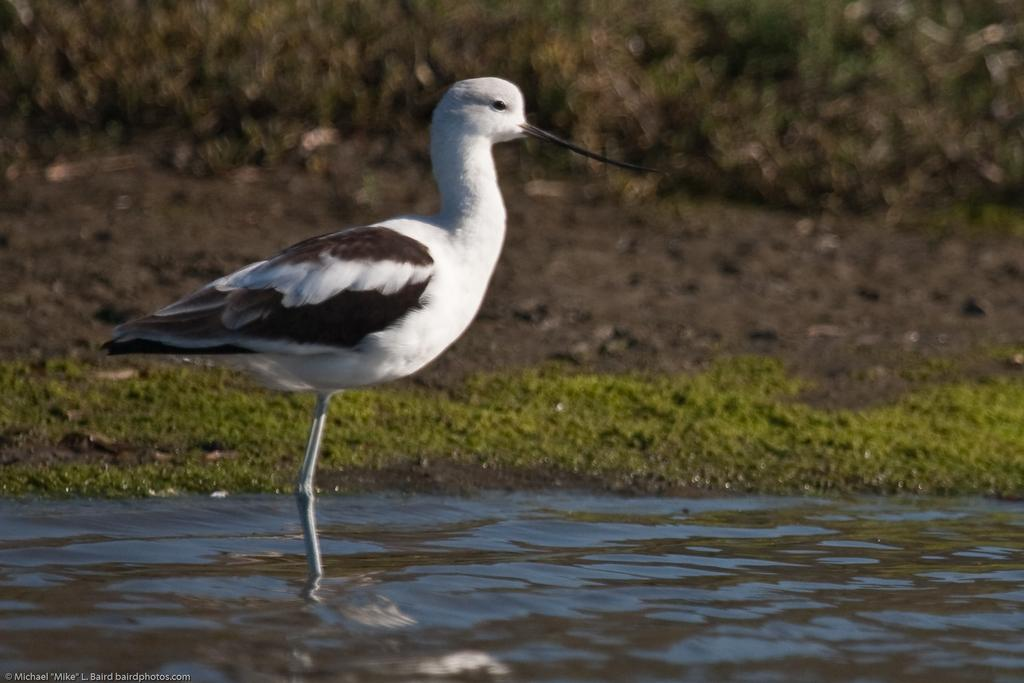What is the bird doing in the image? The bird is standing in the water. What type of vegetation can be seen in the image? There is grass visible in the image. How would you describe the background of the image? The background appears blurry. What type of skate is being used by the bird in the image? There is no skate present in the image; the bird is standing in the water. 